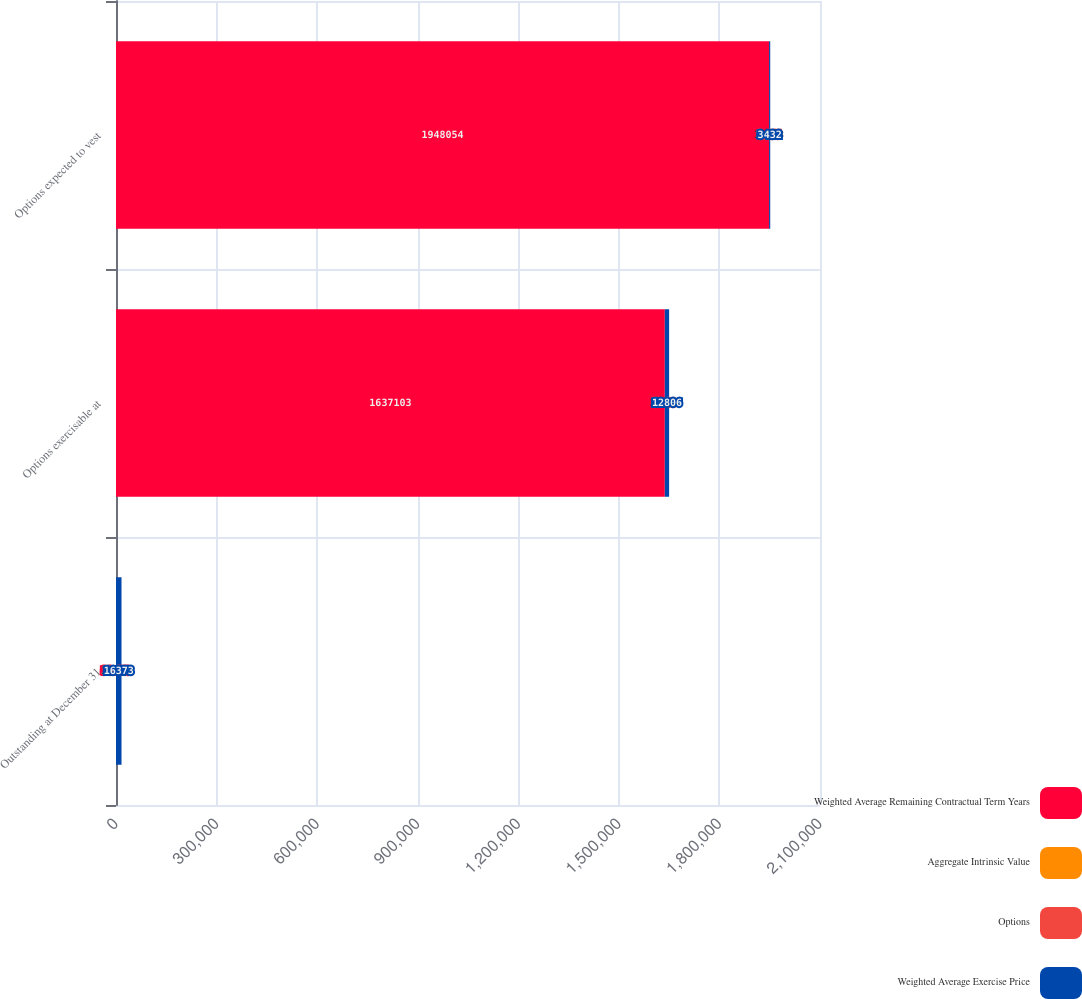Convert chart. <chart><loc_0><loc_0><loc_500><loc_500><stacked_bar_chart><ecel><fcel>Outstanding at December 31<fcel>Options exercisable at<fcel>Options expected to vest<nl><fcel>Weighted Average Remaining Contractual Term Years<fcel>36.73<fcel>1.6371e+06<fcel>1.94805e+06<nl><fcel>Aggregate Intrinsic Value<fcel>34.41<fcel>31.53<fcel>36.73<nl><fcel>Options<fcel>7.28<fcel>5.69<fcel>8.55<nl><fcel>Weighted Average Exercise Price<fcel>16373<fcel>12806<fcel>3432<nl></chart> 